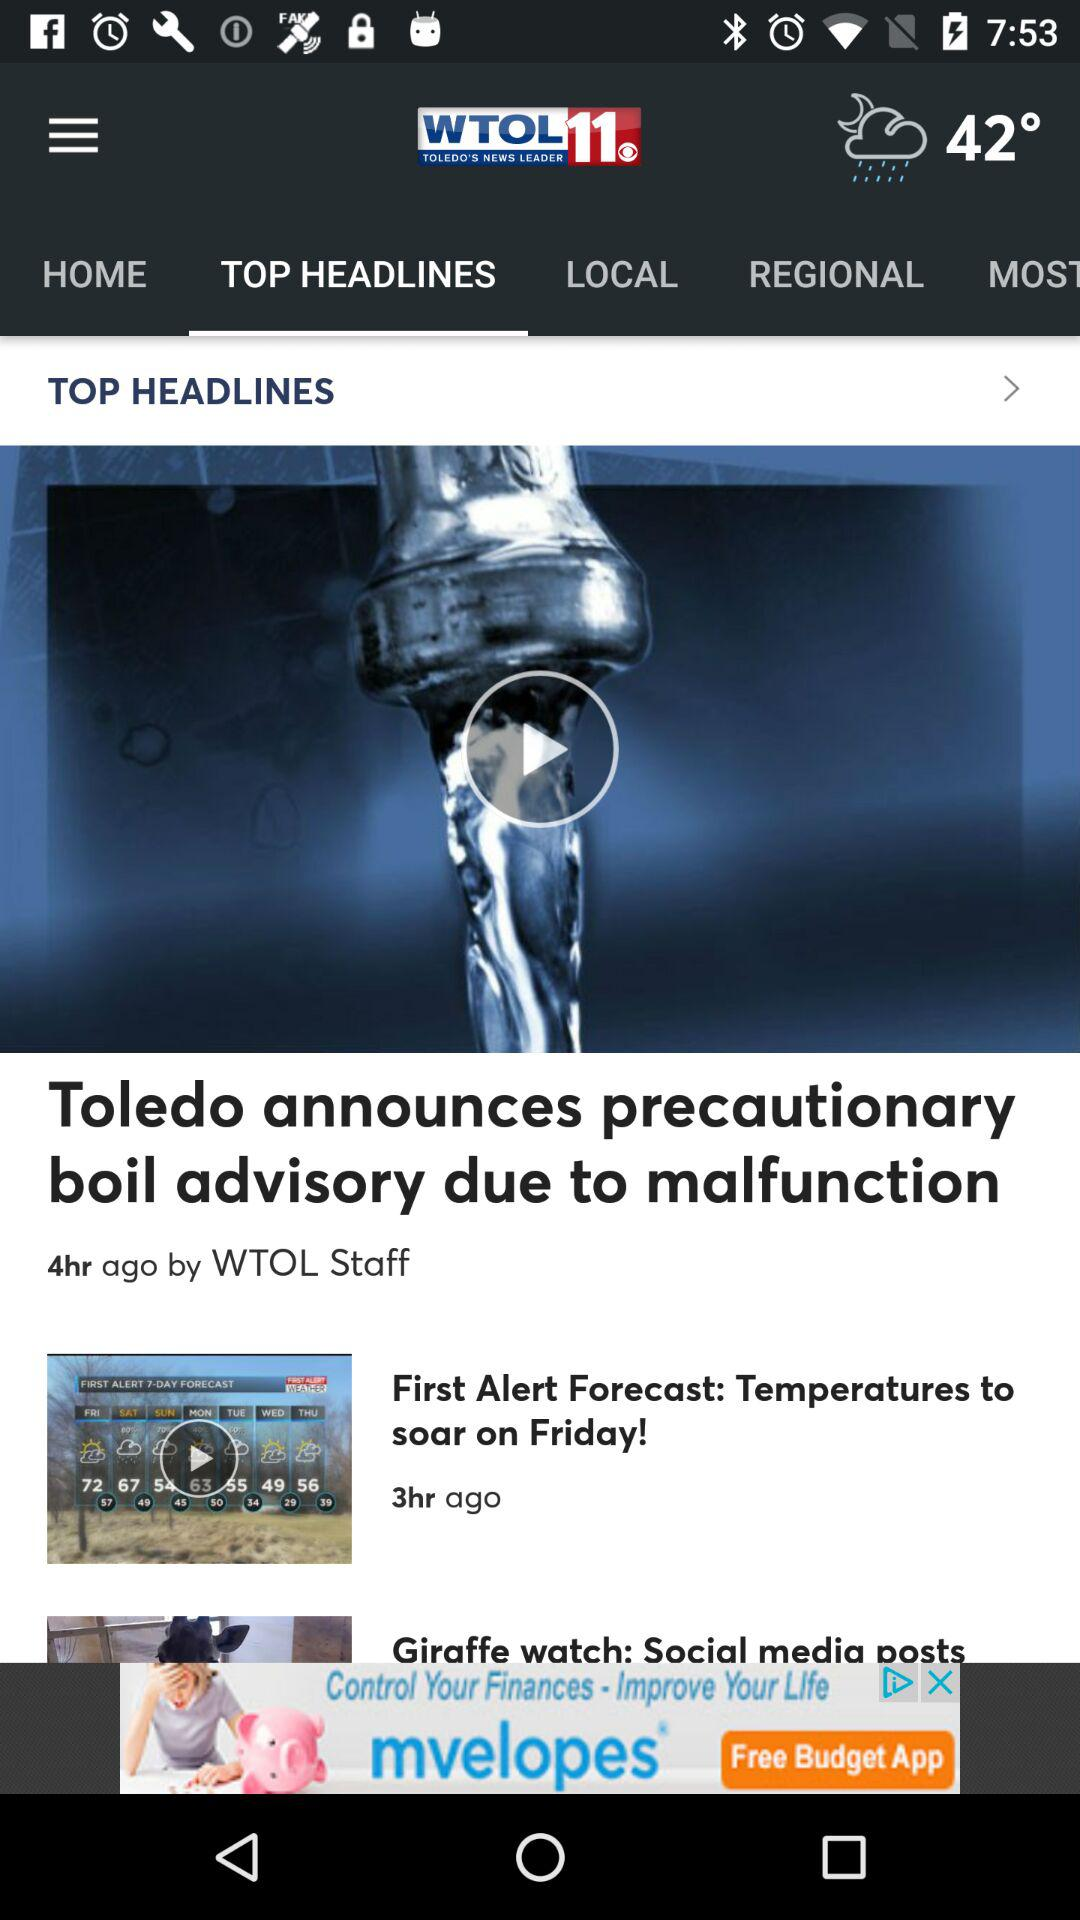Who published the article? The article was published by "WTOL" staff. 